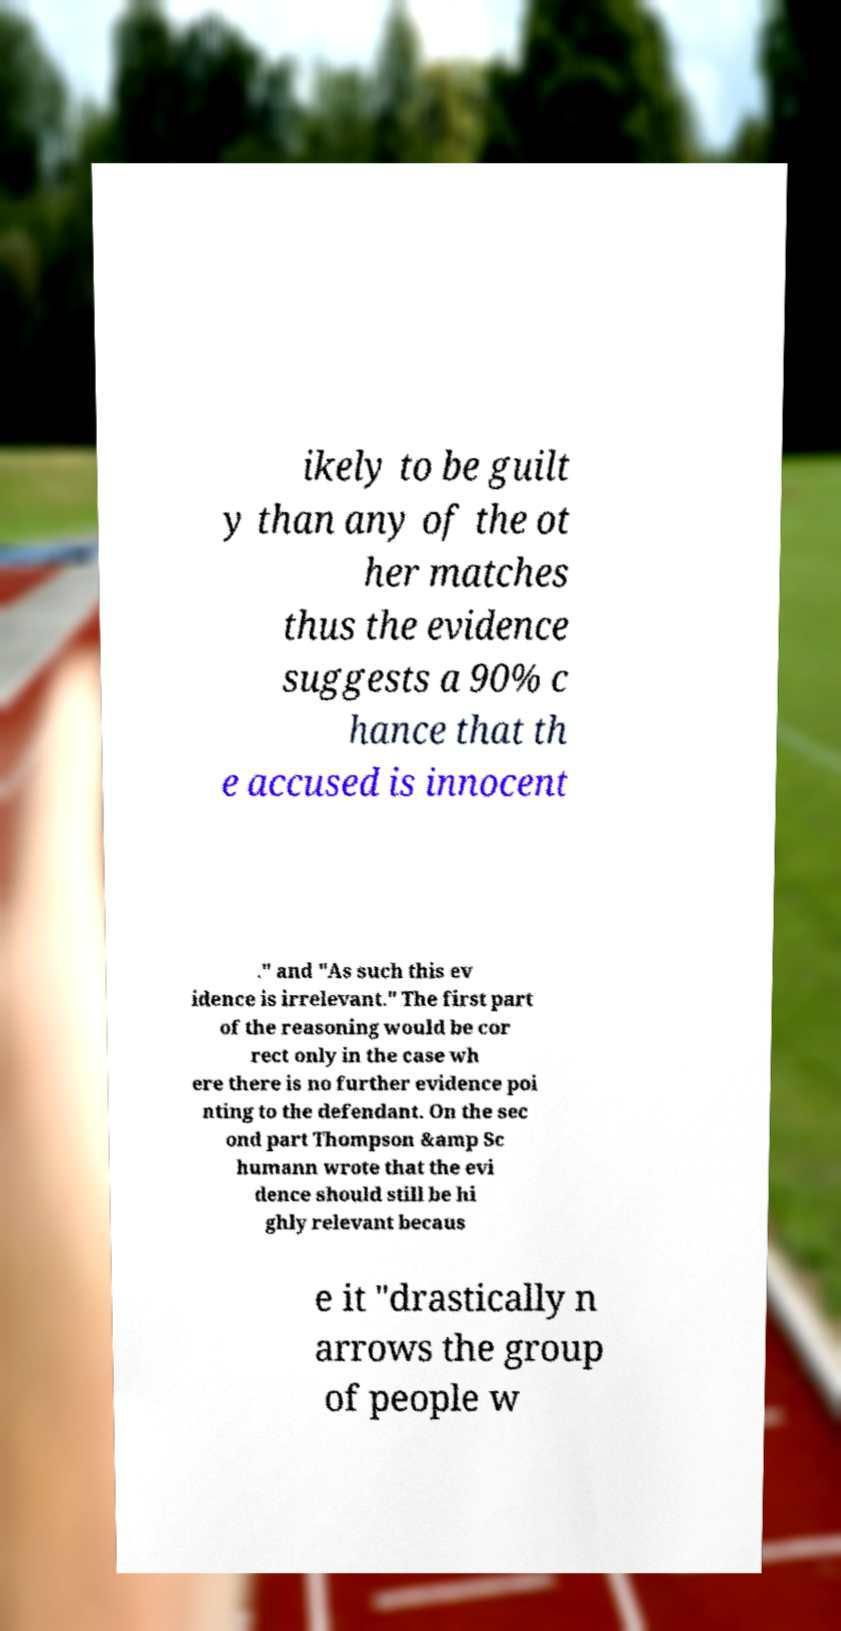Can you read and provide the text displayed in the image?This photo seems to have some interesting text. Can you extract and type it out for me? ikely to be guilt y than any of the ot her matches thus the evidence suggests a 90% c hance that th e accused is innocent ." and "As such this ev idence is irrelevant." The first part of the reasoning would be cor rect only in the case wh ere there is no further evidence poi nting to the defendant. On the sec ond part Thompson &amp Sc humann wrote that the evi dence should still be hi ghly relevant becaus e it "drastically n arrows the group of people w 